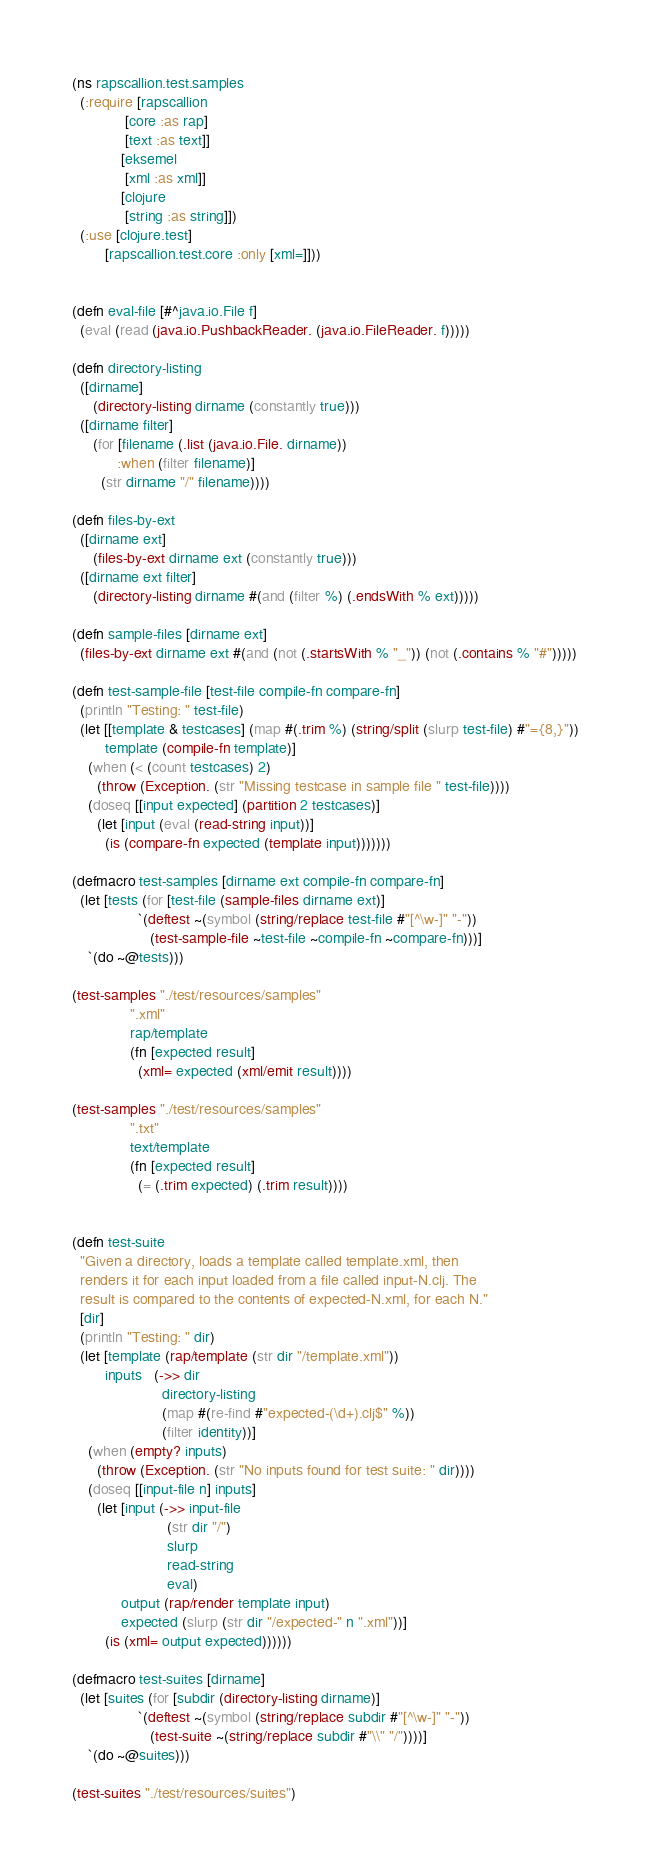Convert code to text. <code><loc_0><loc_0><loc_500><loc_500><_Clojure_>(ns rapscallion.test.samples
  (:require [rapscallion 
             [core :as rap]
             [text :as text]]
            [eksemel
             [xml :as xml]]
            [clojure
             [string :as string]])
  (:use [clojure.test]
        [rapscallion.test.core :only [xml=]]))


(defn eval-file [#^java.io.File f]
  (eval (read (java.io.PushbackReader. (java.io.FileReader. f)))))

(defn directory-listing
  ([dirname]
     (directory-listing dirname (constantly true)))
  ([dirname filter]
     (for [filename (.list (java.io.File. dirname))
           :when (filter filename)]
       (str dirname "/" filename))))

(defn files-by-ext
  ([dirname ext]
     (files-by-ext dirname ext (constantly true)))
  ([dirname ext filter]
     (directory-listing dirname #(and (filter %) (.endsWith % ext)))))

(defn sample-files [dirname ext]
  (files-by-ext dirname ext #(and (not (.startsWith % "_")) (not (.contains % "#")))))

(defn test-sample-file [test-file compile-fn compare-fn]
  (println "Testing: " test-file)
  (let [[template & testcases] (map #(.trim %) (string/split (slurp test-file) #"={8,}"))
        template (compile-fn template)]
    (when (< (count testcases) 2)
      (throw (Exception. (str "Missing testcase in sample file " test-file))))
    (doseq [[input expected] (partition 2 testcases)]
      (let [input (eval (read-string input))]
        (is (compare-fn expected (template input)))))))

(defmacro test-samples [dirname ext compile-fn compare-fn]
  (let [tests (for [test-file (sample-files dirname ext)]
                `(deftest ~(symbol (string/replace test-file #"[^\w-]" "-"))
                   (test-sample-file ~test-file ~compile-fn ~compare-fn)))]
    `(do ~@tests)))

(test-samples "./test/resources/samples"
              ".xml"
              rap/template
              (fn [expected result]
                (xml= expected (xml/emit result))))

(test-samples "./test/resources/samples"
              ".txt"
              text/template
              (fn [expected result]
                (= (.trim expected) (.trim result))))


(defn test-suite
  "Given a directory, loads a template called template.xml, then
  renders it for each input loaded from a file called input-N.clj. The
  result is compared to the contents of expected-N.xml, for each N."
  [dir]
  (println "Testing: " dir)
  (let [template (rap/template (str dir "/template.xml"))
        inputs   (->> dir
                      directory-listing
                      (map #(re-find #"expected-(\d+).clj$" %))
                      (filter identity))]
    (when (empty? inputs)
      (throw (Exception. (str "No inputs found for test suite: " dir))))
    (doseq [[input-file n] inputs]
      (let [input (->> input-file
                       (str dir "/")
                       slurp
                       read-string
                       eval)
            output (rap/render template input)
            expected (slurp (str dir "/expected-" n ".xml"))]
        (is (xml= output expected))))))

(defmacro test-suites [dirname]
  (let [suites (for [subdir (directory-listing dirname)]
                `(deftest ~(symbol (string/replace subdir #"[^\w-]" "-"))
                   (test-suite ~(string/replace subdir #"\\" "/"))))]
    `(do ~@suites)))

(test-suites "./test/resources/suites")


</code> 